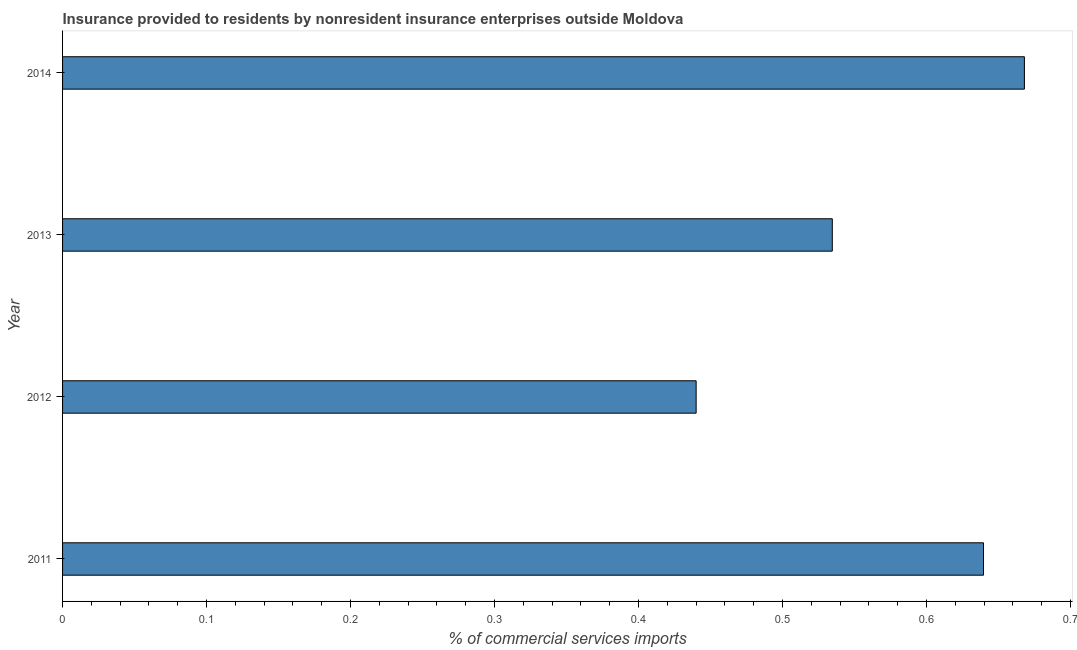Does the graph contain any zero values?
Provide a short and direct response. No. What is the title of the graph?
Your answer should be compact. Insurance provided to residents by nonresident insurance enterprises outside Moldova. What is the label or title of the X-axis?
Ensure brevity in your answer.  % of commercial services imports. What is the insurance provided by non-residents in 2011?
Ensure brevity in your answer.  0.64. Across all years, what is the maximum insurance provided by non-residents?
Keep it short and to the point. 0.67. Across all years, what is the minimum insurance provided by non-residents?
Your answer should be compact. 0.44. In which year was the insurance provided by non-residents maximum?
Offer a very short reply. 2014. In which year was the insurance provided by non-residents minimum?
Your answer should be very brief. 2012. What is the sum of the insurance provided by non-residents?
Provide a short and direct response. 2.28. What is the difference between the insurance provided by non-residents in 2011 and 2012?
Give a very brief answer. 0.2. What is the average insurance provided by non-residents per year?
Give a very brief answer. 0.57. What is the median insurance provided by non-residents?
Provide a succinct answer. 0.59. In how many years, is the insurance provided by non-residents greater than 0.4 %?
Make the answer very short. 4. What is the ratio of the insurance provided by non-residents in 2011 to that in 2012?
Offer a very short reply. 1.45. What is the difference between the highest and the second highest insurance provided by non-residents?
Provide a succinct answer. 0.03. Is the sum of the insurance provided by non-residents in 2012 and 2014 greater than the maximum insurance provided by non-residents across all years?
Your answer should be very brief. Yes. What is the difference between the highest and the lowest insurance provided by non-residents?
Give a very brief answer. 0.23. What is the % of commercial services imports in 2011?
Provide a short and direct response. 0.64. What is the % of commercial services imports in 2012?
Keep it short and to the point. 0.44. What is the % of commercial services imports in 2013?
Ensure brevity in your answer.  0.53. What is the % of commercial services imports in 2014?
Offer a very short reply. 0.67. What is the difference between the % of commercial services imports in 2011 and 2012?
Your answer should be very brief. 0.2. What is the difference between the % of commercial services imports in 2011 and 2013?
Ensure brevity in your answer.  0.11. What is the difference between the % of commercial services imports in 2011 and 2014?
Provide a succinct answer. -0.03. What is the difference between the % of commercial services imports in 2012 and 2013?
Make the answer very short. -0.09. What is the difference between the % of commercial services imports in 2012 and 2014?
Keep it short and to the point. -0.23. What is the difference between the % of commercial services imports in 2013 and 2014?
Make the answer very short. -0.13. What is the ratio of the % of commercial services imports in 2011 to that in 2012?
Provide a short and direct response. 1.45. What is the ratio of the % of commercial services imports in 2011 to that in 2013?
Ensure brevity in your answer.  1.2. What is the ratio of the % of commercial services imports in 2012 to that in 2013?
Offer a very short reply. 0.82. What is the ratio of the % of commercial services imports in 2012 to that in 2014?
Give a very brief answer. 0.66. What is the ratio of the % of commercial services imports in 2013 to that in 2014?
Offer a very short reply. 0.8. 